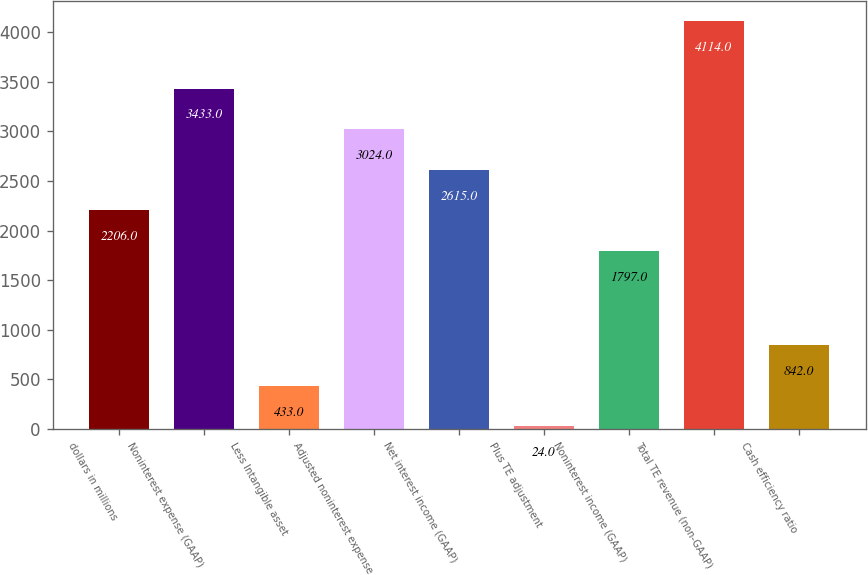Convert chart to OTSL. <chart><loc_0><loc_0><loc_500><loc_500><bar_chart><fcel>dollars in millions<fcel>Noninterest expense (GAAP)<fcel>Less Intangible asset<fcel>Adjusted noninterest expense<fcel>Net interest income (GAAP)<fcel>Plus TE adjustment<fcel>Noninterest income (GAAP)<fcel>Total TE revenue (non-GAAP)<fcel>Cash efficiency ratio<nl><fcel>2206<fcel>3433<fcel>433<fcel>3024<fcel>2615<fcel>24<fcel>1797<fcel>4114<fcel>842<nl></chart> 